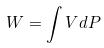Convert formula to latex. <formula><loc_0><loc_0><loc_500><loc_500>W = \int V d P</formula> 